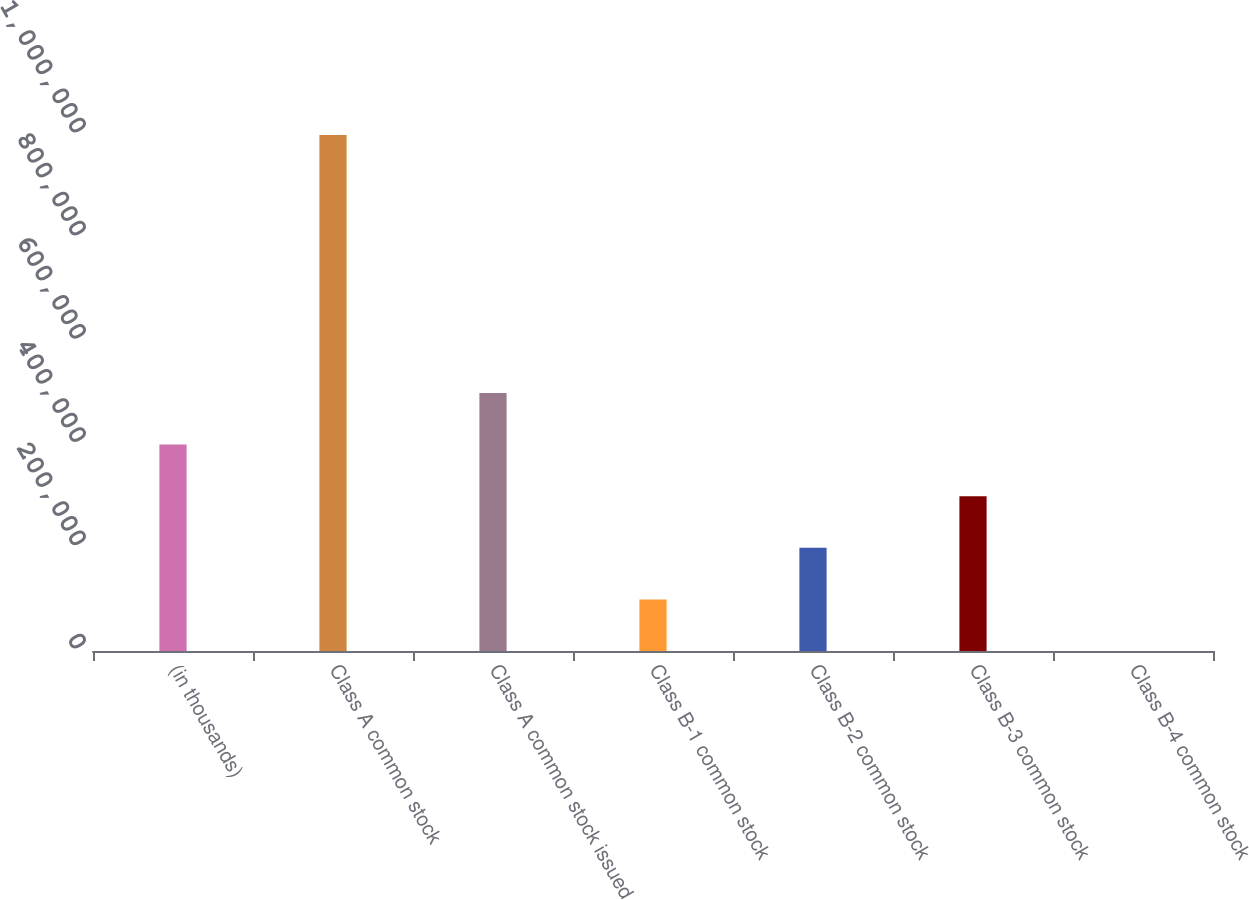<chart> <loc_0><loc_0><loc_500><loc_500><bar_chart><fcel>(in thousands)<fcel>Class A common stock<fcel>Class A common stock issued<fcel>Class B-1 common stock<fcel>Class B-2 common stock<fcel>Class B-3 common stock<fcel>Class B-4 common stock<nl><fcel>400000<fcel>1e+06<fcel>500000<fcel>100000<fcel>200000<fcel>300000<fcel>0.4<nl></chart> 